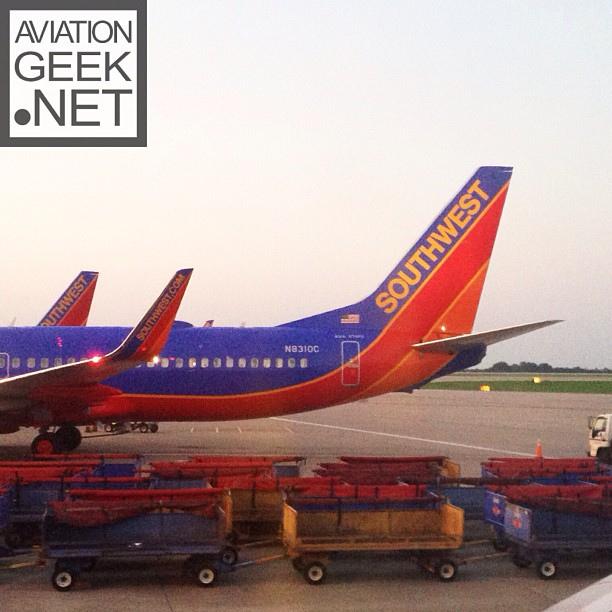Is the plane in the air?
Keep it brief. No. What airline is this?
Keep it brief. Southwest. Which website is advertised in this image?
Concise answer only. Aviationgeeknet. 